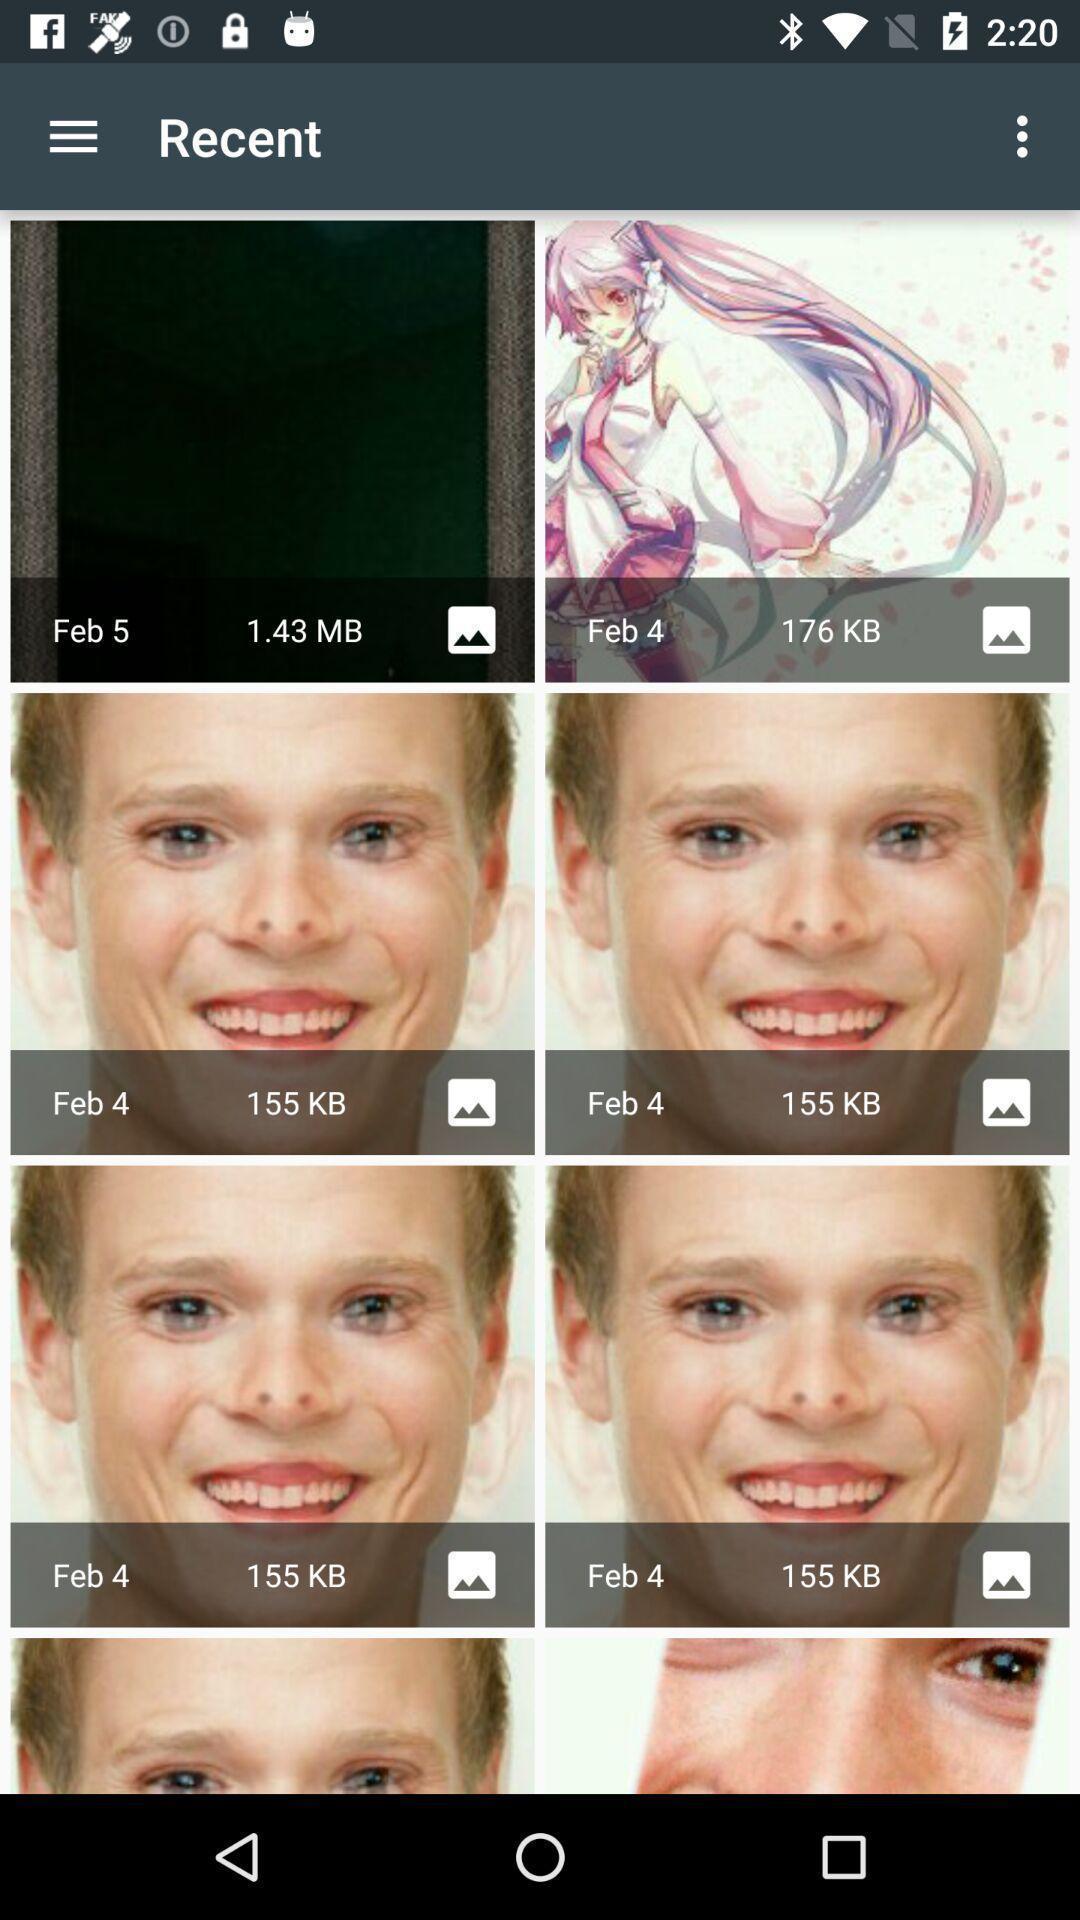Describe the key features of this screenshot. Various images with some effects in the application. 